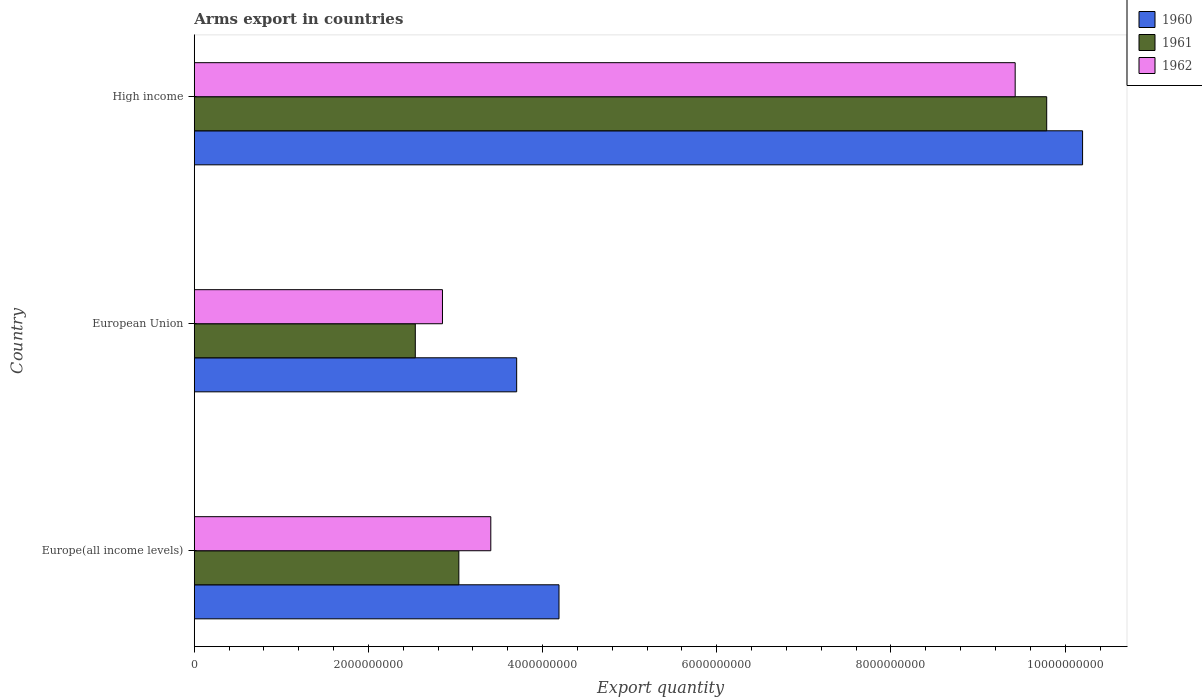What is the total arms export in 1961 in Europe(all income levels)?
Give a very brief answer. 3.04e+09. Across all countries, what is the maximum total arms export in 1960?
Ensure brevity in your answer.  1.02e+1. Across all countries, what is the minimum total arms export in 1961?
Provide a succinct answer. 2.54e+09. In which country was the total arms export in 1961 maximum?
Keep it short and to the point. High income. What is the total total arms export in 1960 in the graph?
Provide a succinct answer. 1.81e+1. What is the difference between the total arms export in 1962 in European Union and that in High income?
Your answer should be compact. -6.58e+09. What is the difference between the total arms export in 1962 in Europe(all income levels) and the total arms export in 1961 in European Union?
Provide a succinct answer. 8.67e+08. What is the average total arms export in 1961 per country?
Your answer should be compact. 5.12e+09. What is the difference between the total arms export in 1962 and total arms export in 1960 in High income?
Offer a terse response. -7.74e+08. In how many countries, is the total arms export in 1960 greater than 4400000000 ?
Your answer should be very brief. 1. What is the ratio of the total arms export in 1961 in Europe(all income levels) to that in High income?
Offer a terse response. 0.31. What is the difference between the highest and the second highest total arms export in 1960?
Give a very brief answer. 6.01e+09. What is the difference between the highest and the lowest total arms export in 1960?
Provide a short and direct response. 6.50e+09. Is the sum of the total arms export in 1961 in Europe(all income levels) and European Union greater than the maximum total arms export in 1962 across all countries?
Your response must be concise. No. Is it the case that in every country, the sum of the total arms export in 1960 and total arms export in 1962 is greater than the total arms export in 1961?
Your response must be concise. Yes. Are the values on the major ticks of X-axis written in scientific E-notation?
Provide a short and direct response. No. Does the graph contain any zero values?
Make the answer very short. No. What is the title of the graph?
Ensure brevity in your answer.  Arms export in countries. Does "2008" appear as one of the legend labels in the graph?
Your answer should be very brief. No. What is the label or title of the X-axis?
Offer a terse response. Export quantity. What is the Export quantity in 1960 in Europe(all income levels)?
Your response must be concise. 4.19e+09. What is the Export quantity in 1961 in Europe(all income levels)?
Offer a terse response. 3.04e+09. What is the Export quantity in 1962 in Europe(all income levels)?
Offer a terse response. 3.40e+09. What is the Export quantity in 1960 in European Union?
Offer a terse response. 3.70e+09. What is the Export quantity in 1961 in European Union?
Your answer should be compact. 2.54e+09. What is the Export quantity in 1962 in European Union?
Give a very brief answer. 2.85e+09. What is the Export quantity in 1960 in High income?
Your response must be concise. 1.02e+1. What is the Export quantity in 1961 in High income?
Your answer should be compact. 9.79e+09. What is the Export quantity in 1962 in High income?
Provide a succinct answer. 9.43e+09. Across all countries, what is the maximum Export quantity of 1960?
Your response must be concise. 1.02e+1. Across all countries, what is the maximum Export quantity of 1961?
Give a very brief answer. 9.79e+09. Across all countries, what is the maximum Export quantity of 1962?
Ensure brevity in your answer.  9.43e+09. Across all countries, what is the minimum Export quantity in 1960?
Provide a short and direct response. 3.70e+09. Across all countries, what is the minimum Export quantity of 1961?
Your answer should be compact. 2.54e+09. Across all countries, what is the minimum Export quantity of 1962?
Provide a short and direct response. 2.85e+09. What is the total Export quantity of 1960 in the graph?
Keep it short and to the point. 1.81e+1. What is the total Export quantity of 1961 in the graph?
Your answer should be compact. 1.54e+1. What is the total Export quantity in 1962 in the graph?
Provide a succinct answer. 1.57e+1. What is the difference between the Export quantity of 1960 in Europe(all income levels) and that in European Union?
Offer a terse response. 4.86e+08. What is the difference between the Export quantity in 1962 in Europe(all income levels) and that in European Union?
Offer a very short reply. 5.55e+08. What is the difference between the Export quantity of 1960 in Europe(all income levels) and that in High income?
Offer a terse response. -6.01e+09. What is the difference between the Export quantity of 1961 in Europe(all income levels) and that in High income?
Your answer should be very brief. -6.75e+09. What is the difference between the Export quantity of 1962 in Europe(all income levels) and that in High income?
Give a very brief answer. -6.02e+09. What is the difference between the Export quantity in 1960 in European Union and that in High income?
Ensure brevity in your answer.  -6.50e+09. What is the difference between the Export quantity in 1961 in European Union and that in High income?
Offer a terse response. -7.25e+09. What is the difference between the Export quantity in 1962 in European Union and that in High income?
Your answer should be very brief. -6.58e+09. What is the difference between the Export quantity in 1960 in Europe(all income levels) and the Export quantity in 1961 in European Union?
Provide a succinct answer. 1.65e+09. What is the difference between the Export quantity in 1960 in Europe(all income levels) and the Export quantity in 1962 in European Union?
Make the answer very short. 1.34e+09. What is the difference between the Export quantity in 1961 in Europe(all income levels) and the Export quantity in 1962 in European Union?
Give a very brief answer. 1.88e+08. What is the difference between the Export quantity in 1960 in Europe(all income levels) and the Export quantity in 1961 in High income?
Offer a terse response. -5.60e+09. What is the difference between the Export quantity in 1960 in Europe(all income levels) and the Export quantity in 1962 in High income?
Offer a terse response. -5.24e+09. What is the difference between the Export quantity in 1961 in Europe(all income levels) and the Export quantity in 1962 in High income?
Ensure brevity in your answer.  -6.39e+09. What is the difference between the Export quantity of 1960 in European Union and the Export quantity of 1961 in High income?
Your answer should be very brief. -6.09e+09. What is the difference between the Export quantity of 1960 in European Union and the Export quantity of 1962 in High income?
Keep it short and to the point. -5.72e+09. What is the difference between the Export quantity in 1961 in European Union and the Export quantity in 1962 in High income?
Your answer should be very brief. -6.89e+09. What is the average Export quantity of 1960 per country?
Offer a terse response. 6.03e+09. What is the average Export quantity of 1961 per country?
Your response must be concise. 5.12e+09. What is the average Export quantity in 1962 per country?
Keep it short and to the point. 5.23e+09. What is the difference between the Export quantity in 1960 and Export quantity in 1961 in Europe(all income levels)?
Your response must be concise. 1.15e+09. What is the difference between the Export quantity in 1960 and Export quantity in 1962 in Europe(all income levels)?
Keep it short and to the point. 7.83e+08. What is the difference between the Export quantity of 1961 and Export quantity of 1962 in Europe(all income levels)?
Your answer should be compact. -3.67e+08. What is the difference between the Export quantity of 1960 and Export quantity of 1961 in European Union?
Your answer should be compact. 1.16e+09. What is the difference between the Export quantity of 1960 and Export quantity of 1962 in European Union?
Your answer should be compact. 8.52e+08. What is the difference between the Export quantity of 1961 and Export quantity of 1962 in European Union?
Your answer should be compact. -3.12e+08. What is the difference between the Export quantity of 1960 and Export quantity of 1961 in High income?
Your response must be concise. 4.12e+08. What is the difference between the Export quantity in 1960 and Export quantity in 1962 in High income?
Provide a succinct answer. 7.74e+08. What is the difference between the Export quantity in 1961 and Export quantity in 1962 in High income?
Your answer should be very brief. 3.62e+08. What is the ratio of the Export quantity of 1960 in Europe(all income levels) to that in European Union?
Provide a succinct answer. 1.13. What is the ratio of the Export quantity in 1961 in Europe(all income levels) to that in European Union?
Give a very brief answer. 1.2. What is the ratio of the Export quantity in 1962 in Europe(all income levels) to that in European Union?
Keep it short and to the point. 1.19. What is the ratio of the Export quantity of 1960 in Europe(all income levels) to that in High income?
Make the answer very short. 0.41. What is the ratio of the Export quantity of 1961 in Europe(all income levels) to that in High income?
Offer a very short reply. 0.31. What is the ratio of the Export quantity of 1962 in Europe(all income levels) to that in High income?
Your response must be concise. 0.36. What is the ratio of the Export quantity of 1960 in European Union to that in High income?
Keep it short and to the point. 0.36. What is the ratio of the Export quantity of 1961 in European Union to that in High income?
Provide a short and direct response. 0.26. What is the ratio of the Export quantity of 1962 in European Union to that in High income?
Make the answer very short. 0.3. What is the difference between the highest and the second highest Export quantity of 1960?
Keep it short and to the point. 6.01e+09. What is the difference between the highest and the second highest Export quantity in 1961?
Your answer should be very brief. 6.75e+09. What is the difference between the highest and the second highest Export quantity in 1962?
Make the answer very short. 6.02e+09. What is the difference between the highest and the lowest Export quantity of 1960?
Keep it short and to the point. 6.50e+09. What is the difference between the highest and the lowest Export quantity in 1961?
Offer a very short reply. 7.25e+09. What is the difference between the highest and the lowest Export quantity of 1962?
Give a very brief answer. 6.58e+09. 